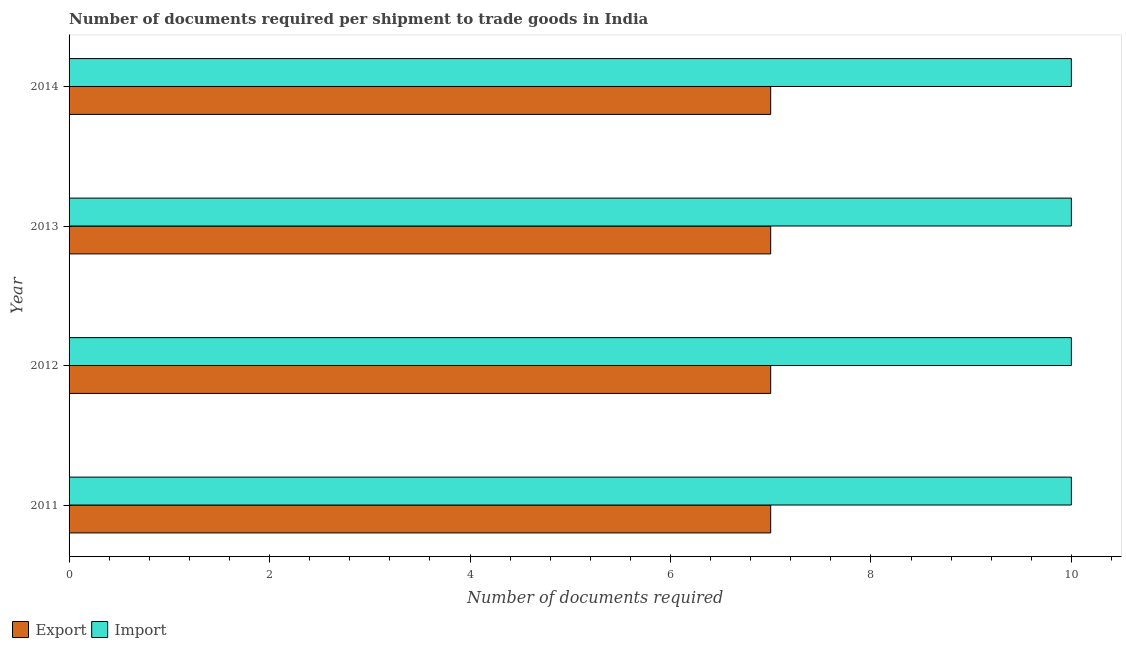How many different coloured bars are there?
Ensure brevity in your answer.  2. Are the number of bars per tick equal to the number of legend labels?
Your answer should be compact. Yes. Are the number of bars on each tick of the Y-axis equal?
Keep it short and to the point. Yes. How many bars are there on the 4th tick from the top?
Give a very brief answer. 2. How many bars are there on the 3rd tick from the bottom?
Give a very brief answer. 2. What is the number of documents required to export goods in 2013?
Your response must be concise. 7. Across all years, what is the maximum number of documents required to import goods?
Provide a succinct answer. 10. Across all years, what is the minimum number of documents required to import goods?
Provide a short and direct response. 10. In which year was the number of documents required to import goods maximum?
Ensure brevity in your answer.  2011. In which year was the number of documents required to export goods minimum?
Give a very brief answer. 2011. What is the total number of documents required to export goods in the graph?
Offer a terse response. 28. What is the difference between the number of documents required to import goods in 2012 and that in 2013?
Make the answer very short. 0. What is the difference between the number of documents required to import goods in 2011 and the number of documents required to export goods in 2012?
Offer a terse response. 3. What is the average number of documents required to export goods per year?
Give a very brief answer. 7. In the year 2011, what is the difference between the number of documents required to export goods and number of documents required to import goods?
Ensure brevity in your answer.  -3. What is the difference between the highest and the second highest number of documents required to import goods?
Provide a short and direct response. 0. What is the difference between the highest and the lowest number of documents required to export goods?
Your response must be concise. 0. What does the 1st bar from the top in 2014 represents?
Your response must be concise. Import. What does the 2nd bar from the bottom in 2013 represents?
Offer a terse response. Import. How many bars are there?
Provide a short and direct response. 8. How many years are there in the graph?
Your answer should be very brief. 4. What is the difference between two consecutive major ticks on the X-axis?
Ensure brevity in your answer.  2. Are the values on the major ticks of X-axis written in scientific E-notation?
Provide a short and direct response. No. Does the graph contain any zero values?
Ensure brevity in your answer.  No. What is the title of the graph?
Ensure brevity in your answer.  Number of documents required per shipment to trade goods in India. Does "Enforce a contract" appear as one of the legend labels in the graph?
Offer a very short reply. No. What is the label or title of the X-axis?
Provide a succinct answer. Number of documents required. What is the Number of documents required of Import in 2011?
Offer a very short reply. 10. What is the Number of documents required in Export in 2012?
Provide a succinct answer. 7. What is the Number of documents required of Import in 2012?
Your answer should be very brief. 10. What is the Number of documents required of Export in 2014?
Your answer should be very brief. 7. What is the Number of documents required in Import in 2014?
Provide a short and direct response. 10. Across all years, what is the maximum Number of documents required of Export?
Offer a very short reply. 7. Across all years, what is the minimum Number of documents required in Export?
Your response must be concise. 7. Across all years, what is the minimum Number of documents required of Import?
Your answer should be compact. 10. What is the total Number of documents required in Export in the graph?
Your answer should be compact. 28. What is the difference between the Number of documents required of Import in 2011 and that in 2013?
Ensure brevity in your answer.  0. What is the difference between the Number of documents required of Export in 2011 and that in 2014?
Ensure brevity in your answer.  0. What is the difference between the Number of documents required in Import in 2011 and that in 2014?
Your answer should be compact. 0. What is the difference between the Number of documents required in Export in 2012 and that in 2013?
Your response must be concise. 0. What is the difference between the Number of documents required of Import in 2012 and that in 2014?
Offer a very short reply. 0. What is the difference between the Number of documents required in Import in 2013 and that in 2014?
Your response must be concise. 0. What is the difference between the Number of documents required of Export in 2011 and the Number of documents required of Import in 2012?
Ensure brevity in your answer.  -3. What is the difference between the Number of documents required of Export in 2011 and the Number of documents required of Import in 2013?
Make the answer very short. -3. What is the difference between the Number of documents required of Export in 2013 and the Number of documents required of Import in 2014?
Make the answer very short. -3. What is the average Number of documents required of Export per year?
Offer a very short reply. 7. In the year 2011, what is the difference between the Number of documents required of Export and Number of documents required of Import?
Your answer should be compact. -3. What is the ratio of the Number of documents required in Import in 2011 to that in 2012?
Provide a short and direct response. 1. What is the ratio of the Number of documents required in Import in 2011 to that in 2014?
Offer a terse response. 1. What is the ratio of the Number of documents required in Export in 2012 to that in 2013?
Your response must be concise. 1. What is the ratio of the Number of documents required in Import in 2012 to that in 2013?
Provide a succinct answer. 1. What is the ratio of the Number of documents required in Import in 2012 to that in 2014?
Your answer should be very brief. 1. What is the difference between the highest and the second highest Number of documents required in Export?
Provide a succinct answer. 0. What is the difference between the highest and the lowest Number of documents required in Import?
Keep it short and to the point. 0. 